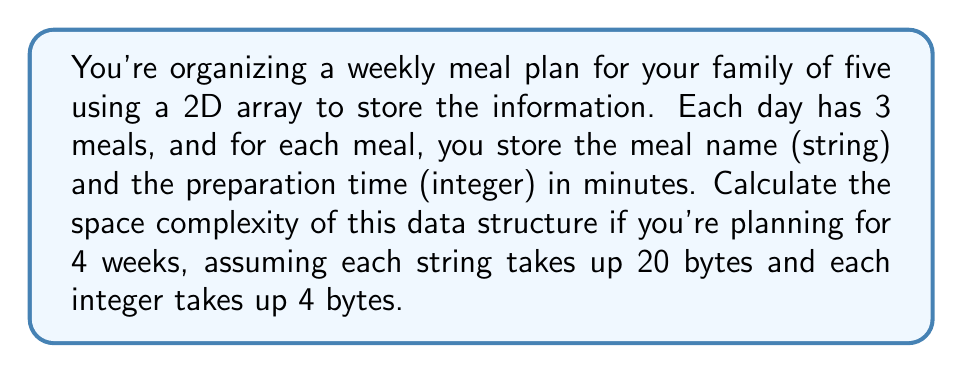Can you answer this question? Let's break this down step-by-step:

1) Structure of the data:
   - 4 weeks
   - 7 days per week
   - 3 meals per day
   - Each meal has 2 pieces of information: name (string) and prep time (integer)

2) Size of each piece of information:
   - String (meal name): 20 bytes
   - Integer (prep time): 4 bytes

3) Calculate the total number of elements:
   $$4 \text{ weeks} \times 7 \text{ days} \times 3 \text{ meals} \times 2 \text{ pieces of info} = 168 \text{ elements}$$

4) Calculate the total space:
   - For strings: $84 \times 20 \text{ bytes} = 1680 \text{ bytes}$
   - For integers: $84 \times 4 \text{ bytes} = 336 \text{ bytes}$
   - Total: $1680 + 336 = 2016 \text{ bytes}$

5) The space complexity is constant as it doesn't depend on any variable input. It's always 2016 bytes for this specific structure.

Therefore, the space complexity is $O(1)$ or constant space.
Answer: $O(1)$ 